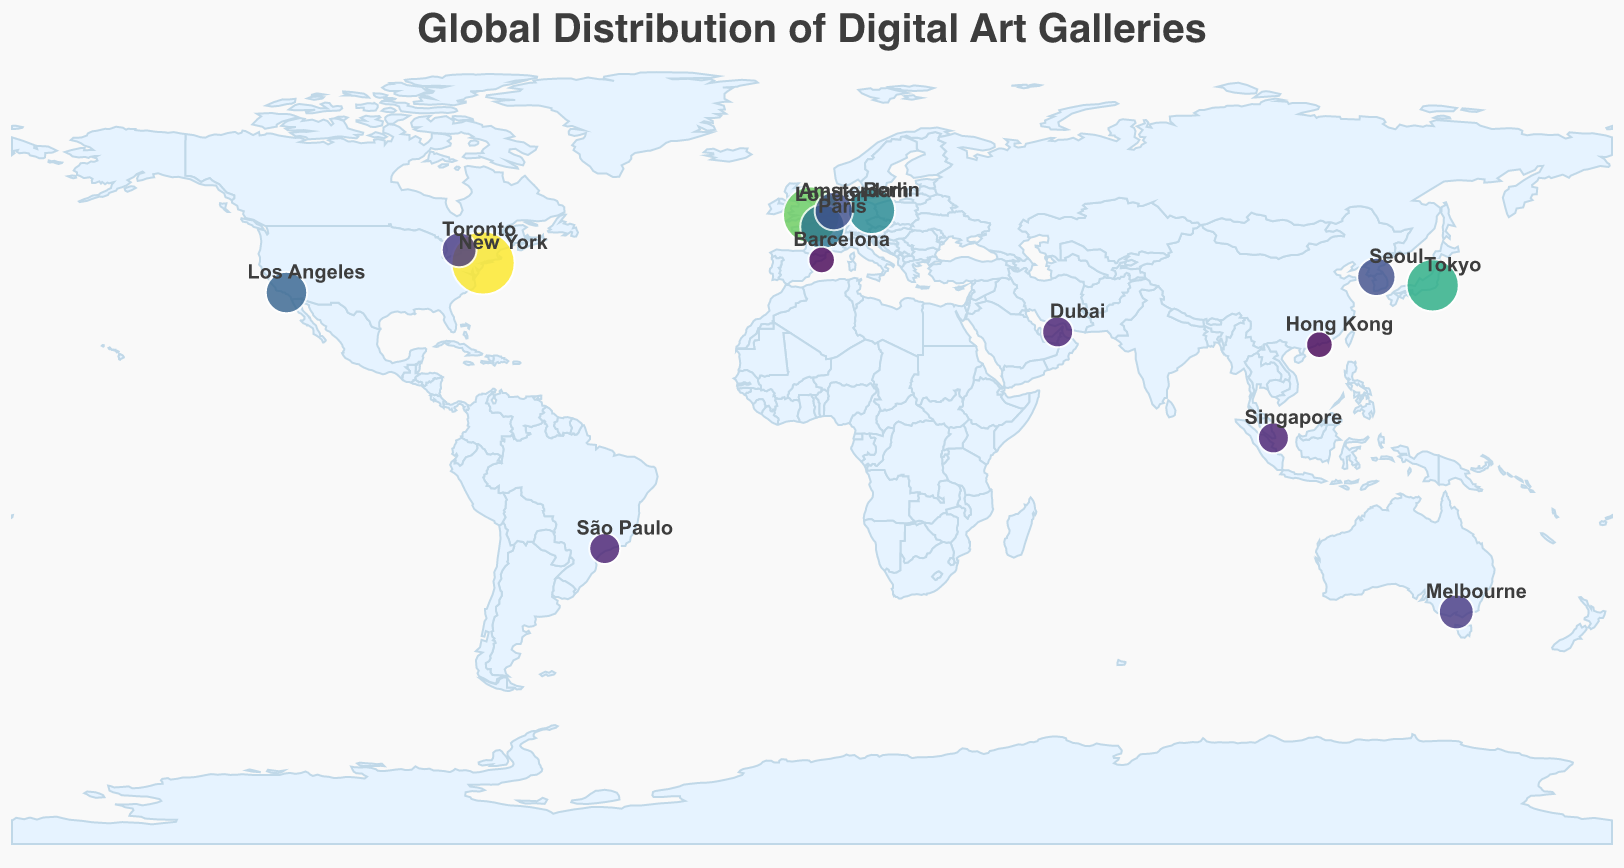Which city has the most digital art galleries? Look for the city with the largest circle. The data shows New York with a count of 15, which is the highest.
Answer: New York Which country appears most frequently on the map? Observe the countries associated with each city. The USA appears twice with New York and Los Angeles.
Answer: USA How many cities have exactly 3 digital art galleries? Identify circles of similar size in the legend marked with "3." The cities are Dubai, São Paulo, and Singapore.
Answer: 3 What is the total number of digital art galleries in Paris and London? Look at the count for both cities: Paris has 7, and London has 12. Sum them up: 7 + 12 = 19
Answer: 19 Which city has fewer digital art galleries, Tokyo or Berlin? Compare the size of the circles; Tokyo has 10, and Berlin has 8. Since 8 is less than 10, Berlin has fewer galleries.
Answer: Berlin In which hemisphere are most digital art galleries located? Determine which side of the equator (latitude) the majority of points are on. Most points are in the Northern Hemisphere.
Answer: Northern Hemisphere Which city in Canada is listed in the data? The tooltip provides the names of the cities along with their countries. Toronto is the only city from Canada.
Answer: Toronto Do the cities with fewer than 5 digital art galleries exhibit any regional patterns? Identify and observe the locations of cities with circles sized under 5: Barcelona, Hong Kong, Dubai, São Paulo, and Singapore. They spread across different continents with no immediate regional concentration seen.
Answer: No clear regional pattern Identify one key visual feature helping to understand the geographic distribution of art galleries. Note that circle size (radius) on the map represents the number of galleries, making it immediately clear where clusters of galleries are.
Answer: Circle size represents number of galleries 